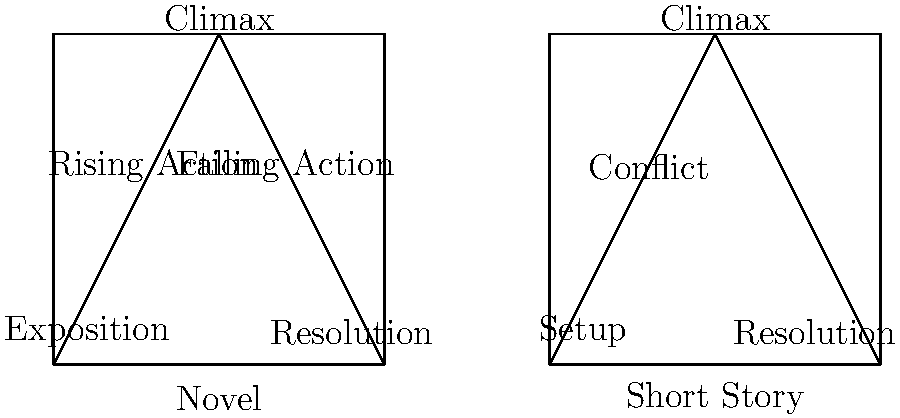Analyze the plot diagrams provided for a novel and a short story. How do these narrative structures differ, and what implications do these differences have for the storytelling techniques employed in each genre? 1. Novel structure:
   a. Exposition: Introduces characters, setting, and initial situation
   b. Rising Action: Develops conflicts and builds tension
   c. Climax: Peak of tension and turning point
   d. Falling Action: Consequences of the climax unfold
   e. Resolution: Conflicts are resolved, and loose ends are tied up

2. Short Story structure:
   a. Setup: Quickly introduces characters and situation
   b. Conflict: Immediately presents the main problem
   c. Climax: Rapidly reaches the turning point
   d. Resolution: Swiftly concludes the story

3. Key differences:
   a. Complexity: Novels have a more complex structure with additional stages
   b. Pacing: Short stories have a faster pace, moving quickly through stages
   c. Character development: Novels allow for more in-depth character exploration
   d. Subplots: Novels can accommodate multiple subplots, while short stories focus on a single plot line

4. Implications for storytelling techniques:
   a. Novels:
      - Allow for more detailed world-building and character development
      - Can explore multiple themes and subplots
      - Provide space for gradual tension build-up and complex resolutions
   b. Short Stories:
      - Require concise and efficient storytelling
      - Focus on a single, impactful moment or revelation
      - Employ more immediate hooks and faster pacing

5. Adaptations for teaching:
   - Use novel structure for long-term writing projects and in-depth literary analysis
   - Employ short story structure for focused writing exercises and quick narrative studies
Answer: Novels have a more complex structure allowing for detailed development, while short stories have a condensed structure focusing on a single, impactful narrative arc, resulting in different storytelling techniques for pacing, character development, and plot complexity. 